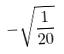Convert formula to latex. <formula><loc_0><loc_0><loc_500><loc_500>- \sqrt { \frac { 1 } { 2 0 } }</formula> 